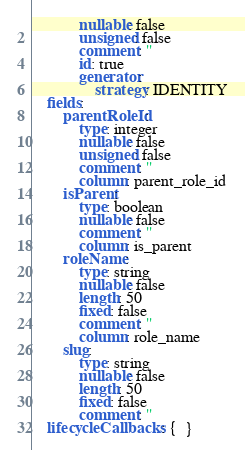Convert code to text. <code><loc_0><loc_0><loc_500><loc_500><_YAML_>            nullable: false
            unsigned: false
            comment: ''
            id: true
            generator:
                strategy: IDENTITY
    fields:
        parentRoleId:
            type: integer
            nullable: false
            unsigned: false
            comment: ''
            column: parent_role_id
        isParent:
            type: boolean
            nullable: false
            comment: ''
            column: is_parent
        roleName:
            type: string
            nullable: false
            length: 50
            fixed: false
            comment: ''
            column: role_name
        slug:
            type: string
            nullable: false
            length: 50
            fixed: false
            comment: ''
    lifecycleCallbacks: {  }
</code> 